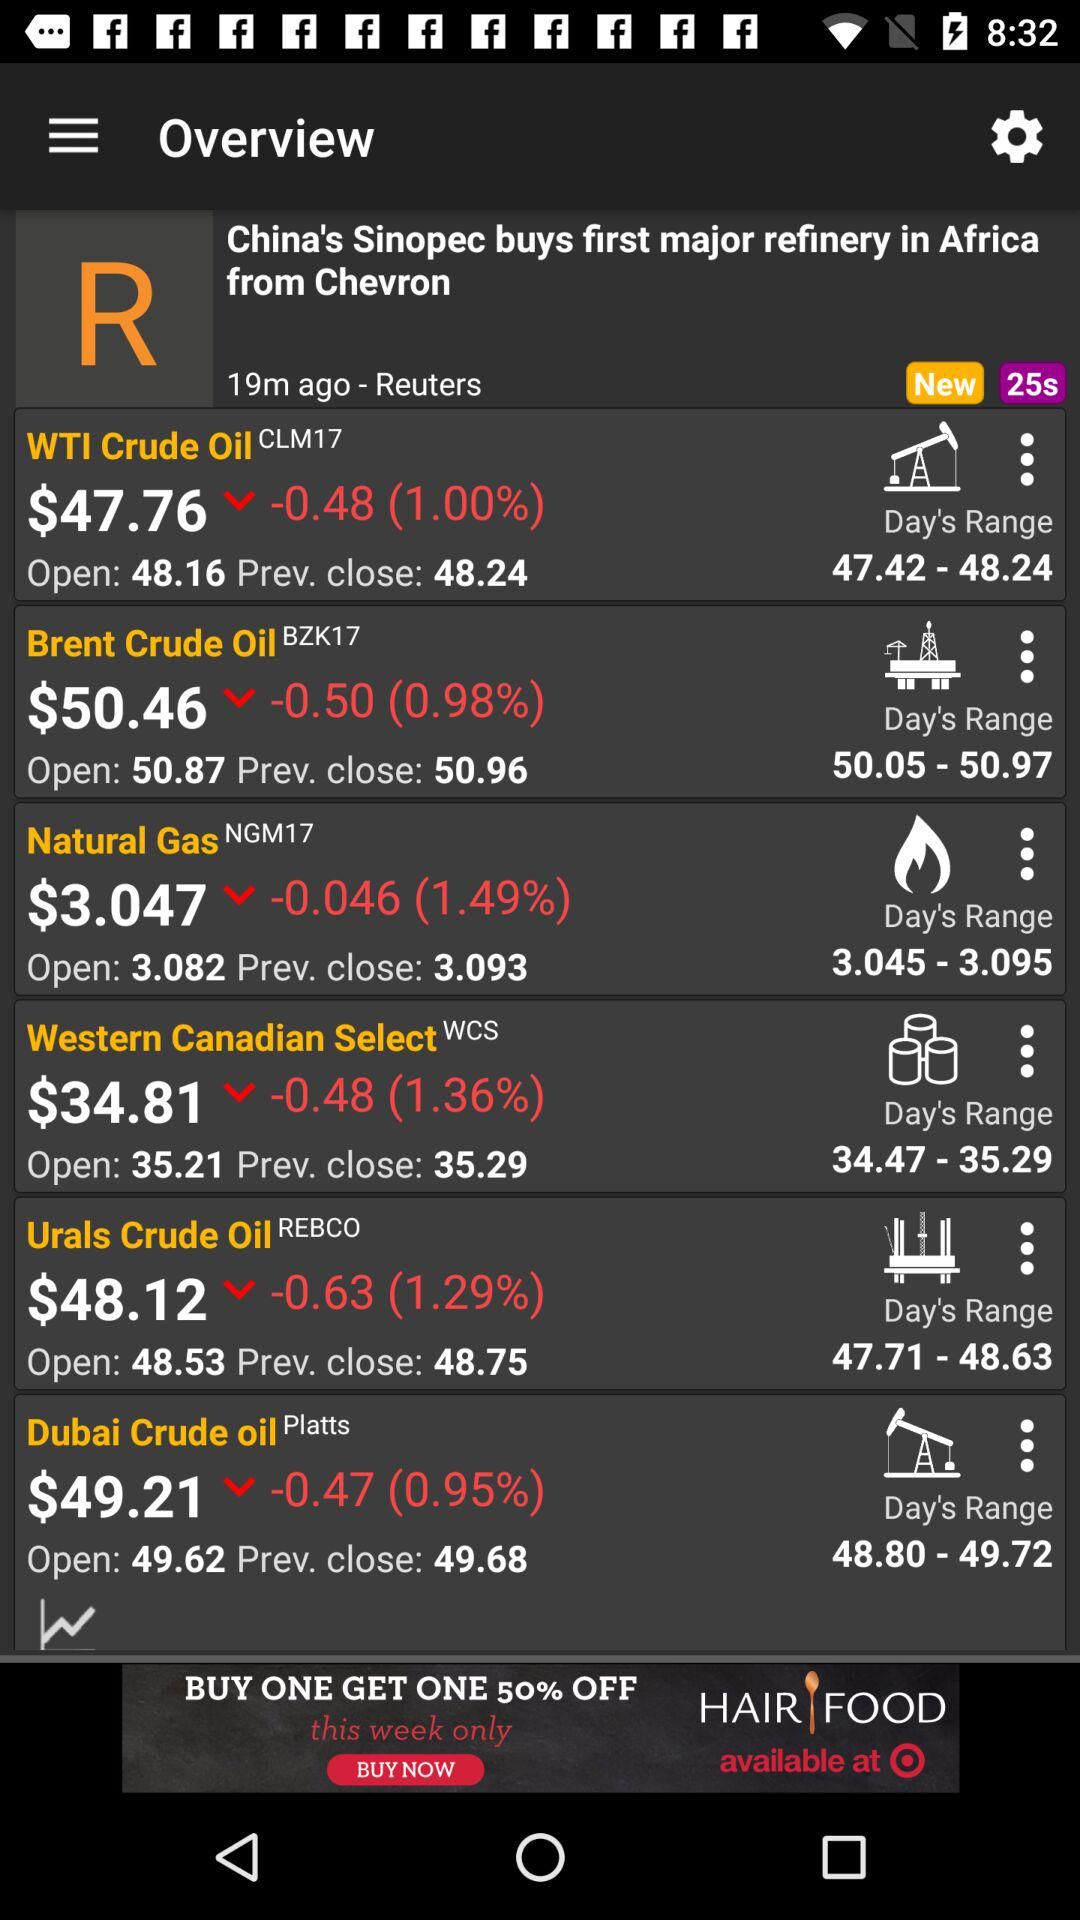What is the percentage change in the price of WTI Crude Oil between the open and close?
Answer the question using a single word or phrase. -0.48% 